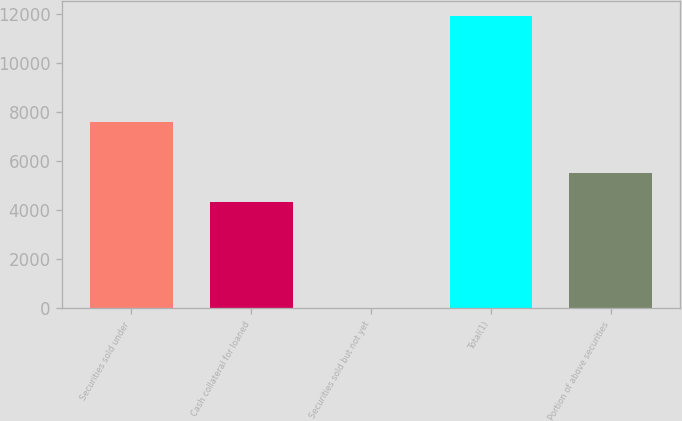Convert chart to OTSL. <chart><loc_0><loc_0><loc_500><loc_500><bar_chart><fcel>Securities sold under<fcel>Cash collateral for loaned<fcel>Securities sold but not yet<fcel>Total(1)<fcel>Portion of above securities<nl><fcel>7606<fcel>4333<fcel>2<fcel>11941<fcel>5526.9<nl></chart> 